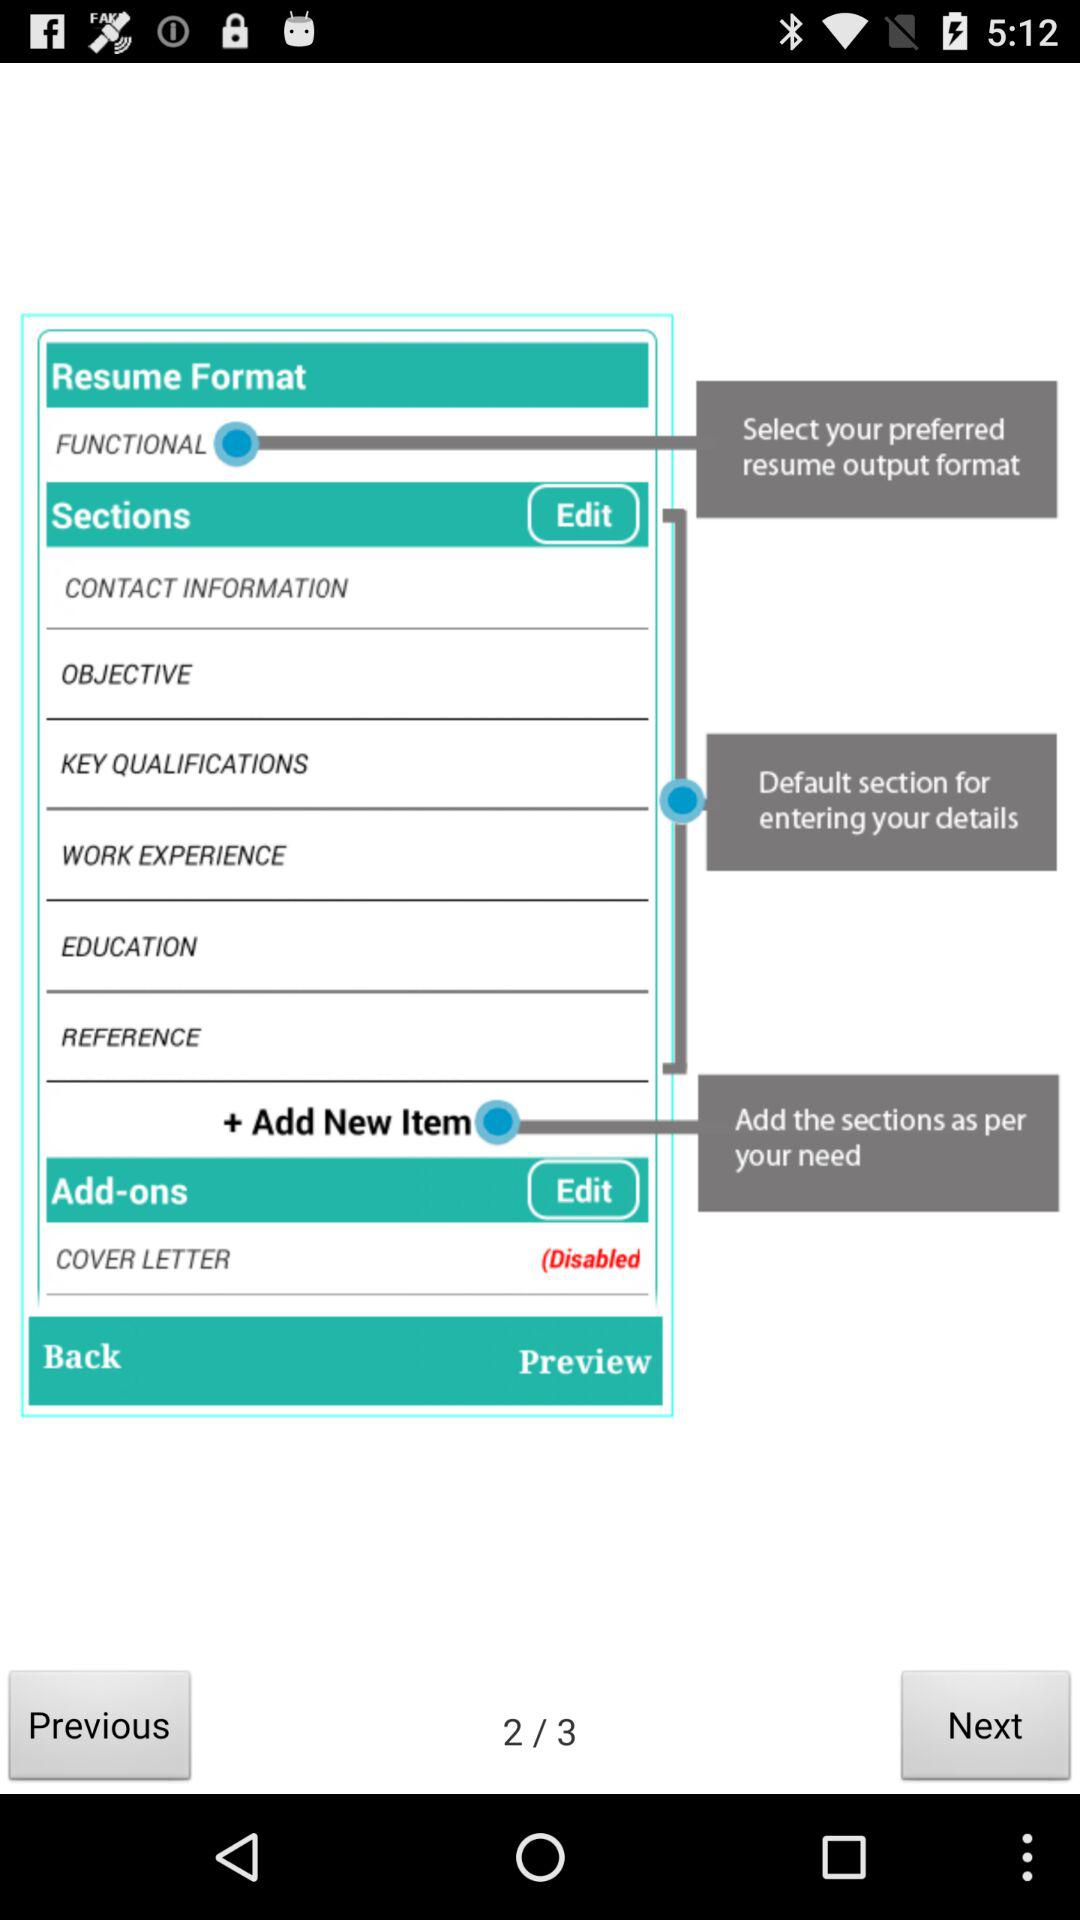What is the total number of pages? The total number of pages is 3. 